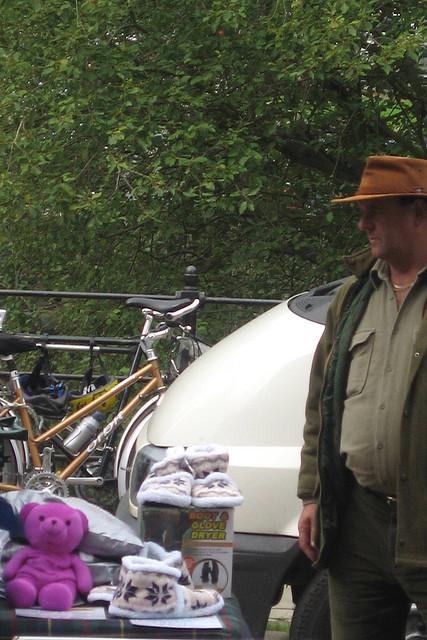Are there any bicycles in the picture?
Concise answer only. Yes. How many bears are there?
Concise answer only. 1. What kind of vehicle is shown?
Answer briefly. Bicycle. What is on top of the man's head in this picture?
Answer briefly. Hat. 